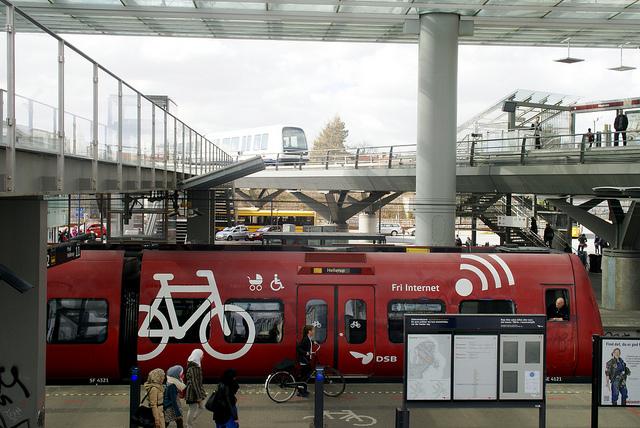What color is the train?
Answer briefly. Red. Is this train blue?
Quick response, please. No. What language is spoken?
Write a very short answer. English. What image is painted between the images of a bicycle and a wheelchair?
Concise answer only. Baby carriage. What color is the vehicle?
Quick response, please. Red. What is the bike next to?
Be succinct. Train. What kind of vehicle is shown?
Be succinct. Train. Is the train in the image modem?
Short answer required. Yes. 